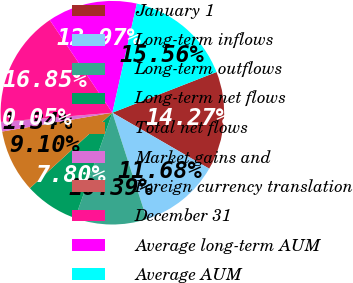Convert chart. <chart><loc_0><loc_0><loc_500><loc_500><pie_chart><fcel>January 1<fcel>Long-term inflows<fcel>Long-term outflows<fcel>Long-term net flows<fcel>Total net flows<fcel>Market gains and<fcel>Foreign currency translation<fcel>December 31<fcel>Average long-term AUM<fcel>Average AUM<nl><fcel>14.27%<fcel>11.68%<fcel>10.39%<fcel>7.8%<fcel>9.1%<fcel>1.34%<fcel>0.05%<fcel>16.85%<fcel>12.97%<fcel>15.56%<nl></chart> 